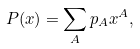<formula> <loc_0><loc_0><loc_500><loc_500>P ( x ) = \sum _ { A } p _ { A } x ^ { A } ,</formula> 